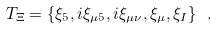<formula> <loc_0><loc_0><loc_500><loc_500>T _ { \Xi } = \{ \xi _ { 5 } , i \xi _ { \mu 5 } , i \xi _ { \mu \nu } , \xi _ { \mu } , \xi _ { I } \} \ .</formula> 